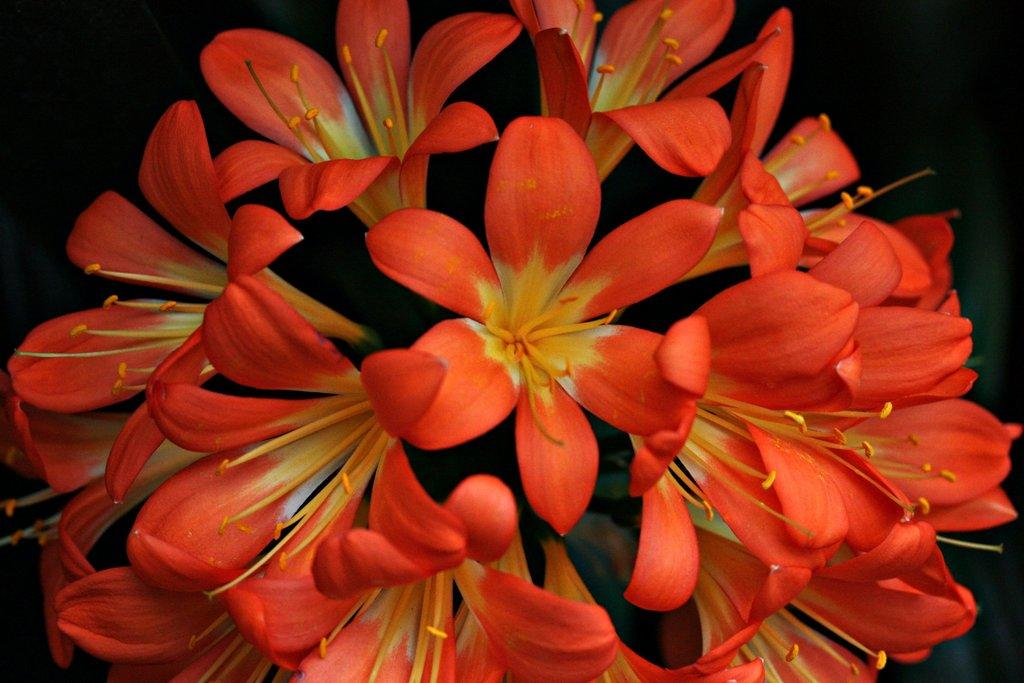What type of plants are in the image? There are flowers in the image. What colors are the flowers? The flowers are red and yellow in color. How many apples are hanging from the flowers in the image? There are no apples present in the image; it features flowers in red and yellow colors. What type of sound do the bells make in the image? There are no bells present in the image; it features flowers in red and yellow colors. 